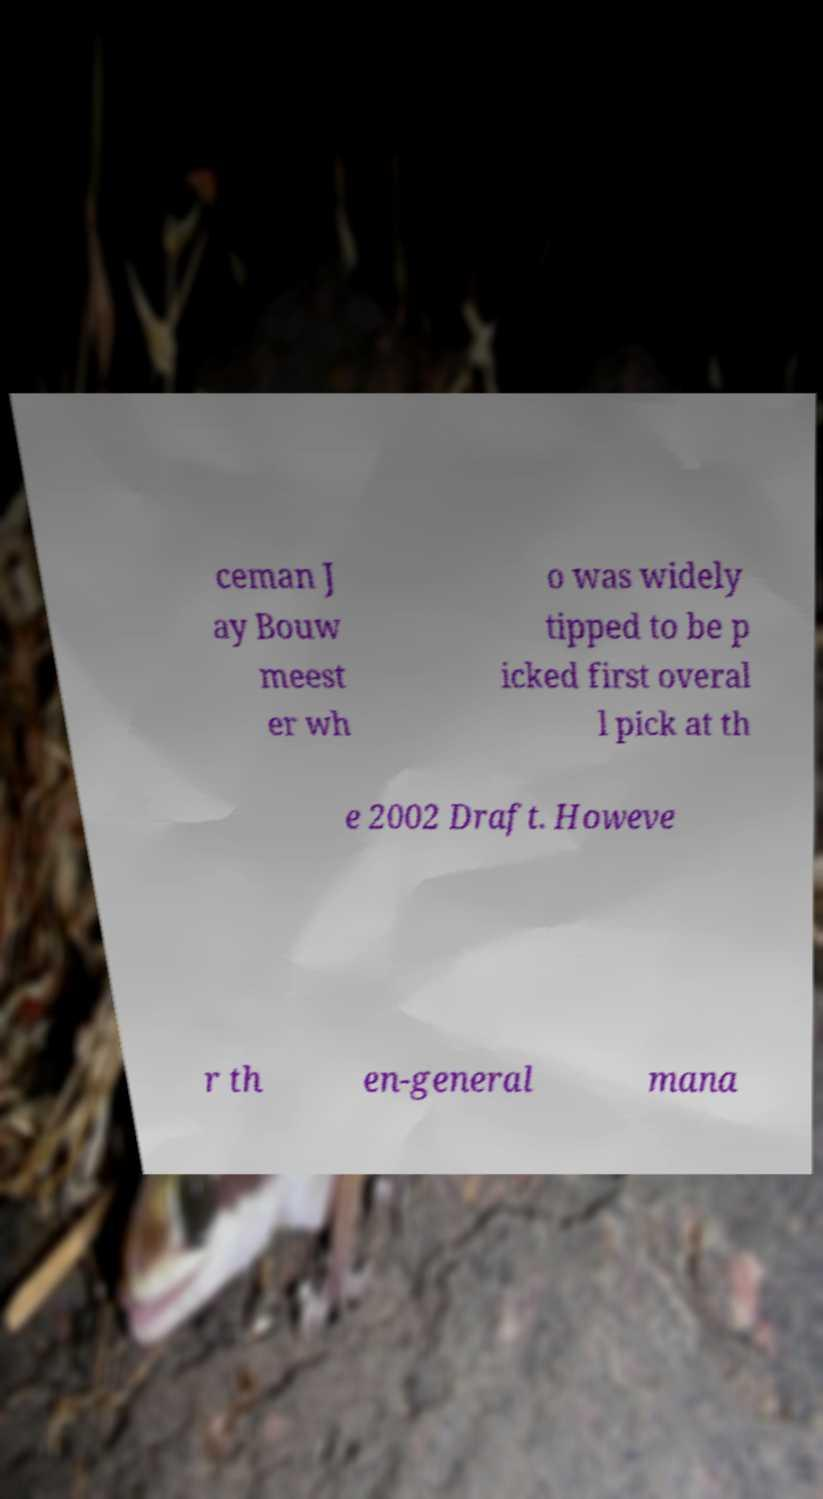Could you extract and type out the text from this image? ceman J ay Bouw meest er wh o was widely tipped to be p icked first overal l pick at th e 2002 Draft. Howeve r th en-general mana 